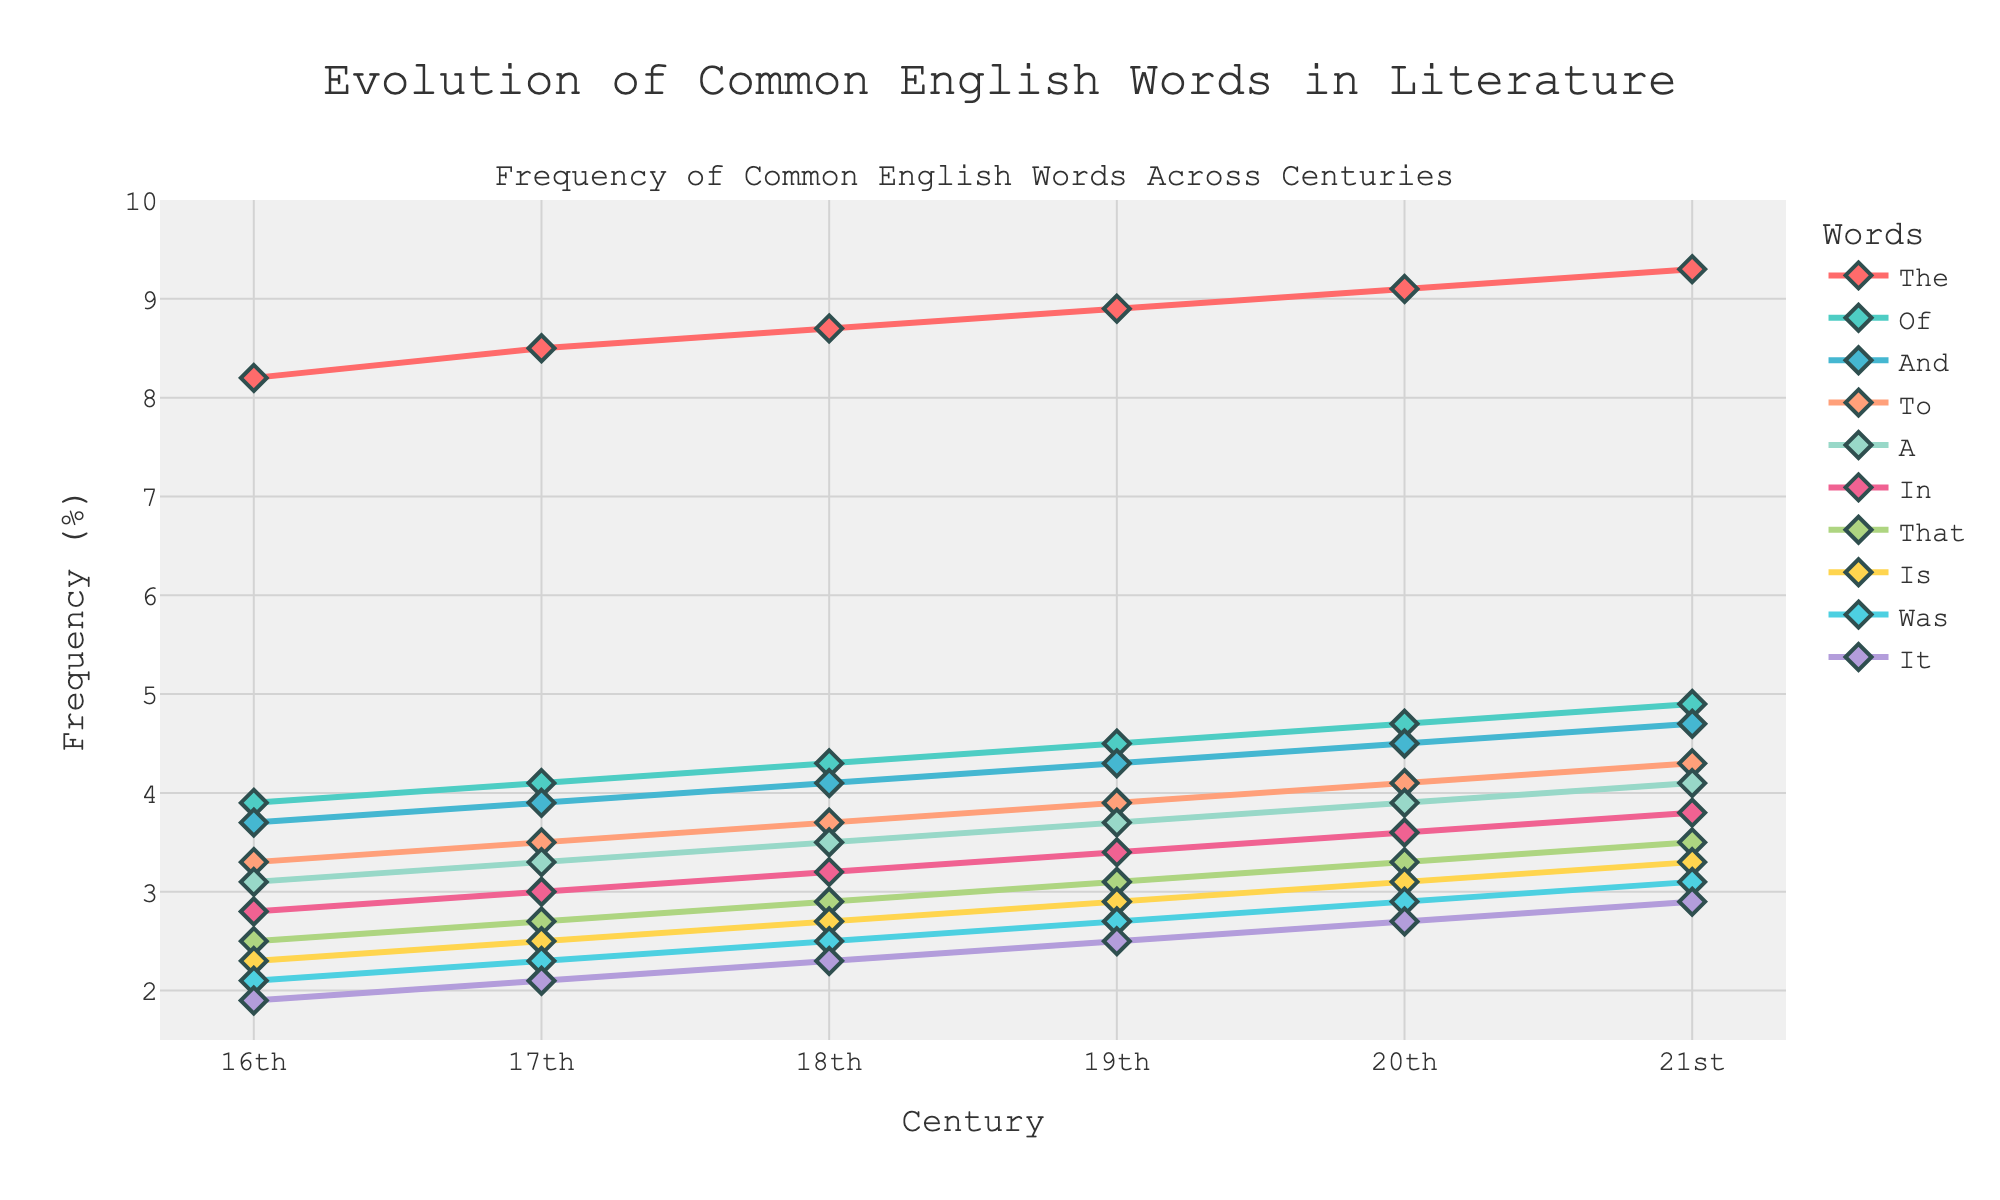Which word has the highest frequency in the 21st century? The word "the" has the highest frequency in the 21st century. To determine this, look at the plot and find the value corresponding to each word in the 21st century. The word "the" has the highest frequency value of 9.3%.
Answer: The Which word has shown a consistent increase in usage across all centuries? The word "the" has shown a consistent increase in usage across all centuries. By tracing the line for "the" from the 16th to 21st century, we observe a steady upward trend.
Answer: The What is the difference in frequency of the word "and" between the 16th and 21st centuries? To find the difference, look at the frequencies for "and" in both centuries. In the 16th century, it is 3.7%, and in the 21st century, it is 4.7%. The difference is 4.7% - 3.7% = 1.0%.
Answer: 1.0% Among the words "of" and "to," which one had a greater increase in frequency from the 16th century to the 21st century? First, note the frequencies in the 16th and 21st centuries for both words: "of" is 3.9% to 4.9%, and "to" is 3.3% to 4.3%. The increase for "of" is 1% and for "to" is 1%. Therefore, both had an equal increase of 1%.
Answer: Both In which century did the word "was" first exceed a frequency of 2.5%? Look at the trend line for "was". It crosses the 2.5% mark in the 18th century. Verify by checking that the frequency in the 18th century is indeed 2.5% or higher.
Answer: 18th century What is the average frequency of the word "in" across all centuries? Add up the frequencies of "in" for all centuries and then divide by the number of centuries: (2.8 + 3.0 + 3.2 + 3.4 + 3.6 + 3.8) / 6 = 19.8 / 6 = 3.3%.
Answer: 3.3% Is there a word that remains below a frequency of 3.0% in all centuries? Scan through the plot and observe if any word’s line stays below the 3.0% mark consistently. The word "it" remains below 3.0% in all centuries.
Answer: It Which century shows the highest overall frequencies for the top 10 words combined? Add the frequencies for each century and compare: 16th (34.8%), 17th (35.9%), 18th (37.4%), 19th (39.6%), 20th (42.8%), 21st (45.8%). The 21st century has the highest combined frequency.
Answer: 21st century Which word most closely follows the frequency trend of the word "the"? Observe the plot for lines that closely mirror the trend line for "the." The word "of" shows a similar upward trend but not identical. Closely observe all trends to confirm "of" has the closest pattern in resemblance to "the."
Answer: Of How many words have a frequency that exceeded 4.0% in the 20th century? Check the values for each word in the 20th century and count the ones exceeding 4.0%. The words are: "the" (9.1%), "of" (4.7%), "and" (4.5%), and "to" (4.1%). There are 4 words.
Answer: 4 